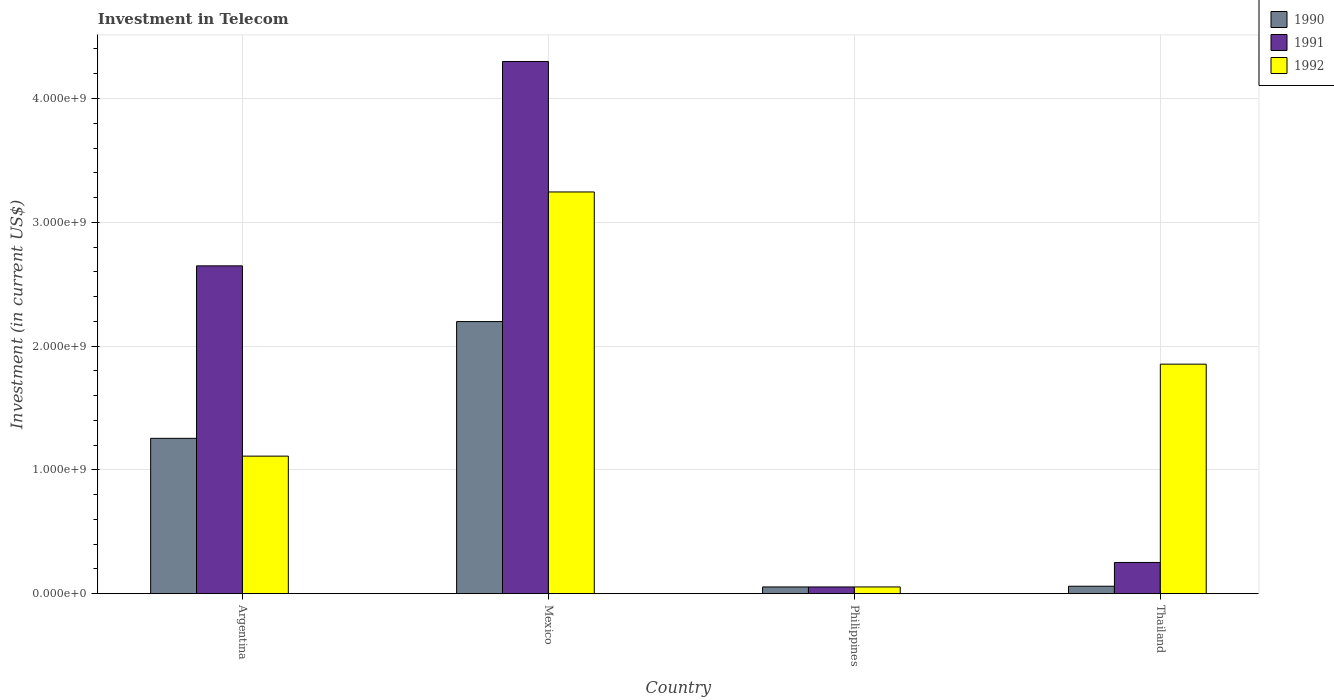How many different coloured bars are there?
Give a very brief answer. 3. How many groups of bars are there?
Provide a succinct answer. 4. Are the number of bars on each tick of the X-axis equal?
Your answer should be compact. Yes. How many bars are there on the 3rd tick from the left?
Give a very brief answer. 3. How many bars are there on the 3rd tick from the right?
Offer a terse response. 3. What is the label of the 2nd group of bars from the left?
Give a very brief answer. Mexico. What is the amount invested in telecom in 1991 in Thailand?
Make the answer very short. 2.52e+08. Across all countries, what is the maximum amount invested in telecom in 1990?
Your answer should be very brief. 2.20e+09. Across all countries, what is the minimum amount invested in telecom in 1991?
Give a very brief answer. 5.42e+07. In which country was the amount invested in telecom in 1990 minimum?
Give a very brief answer. Philippines. What is the total amount invested in telecom in 1991 in the graph?
Give a very brief answer. 7.25e+09. What is the difference between the amount invested in telecom in 1992 in Mexico and that in Philippines?
Your answer should be very brief. 3.19e+09. What is the difference between the amount invested in telecom in 1991 in Mexico and the amount invested in telecom in 1990 in Philippines?
Provide a short and direct response. 4.24e+09. What is the average amount invested in telecom in 1992 per country?
Your answer should be very brief. 1.57e+09. What is the difference between the amount invested in telecom of/in 1992 and amount invested in telecom of/in 1991 in Argentina?
Provide a succinct answer. -1.54e+09. What is the ratio of the amount invested in telecom in 1991 in Argentina to that in Thailand?
Your answer should be very brief. 10.51. Is the amount invested in telecom in 1990 in Philippines less than that in Thailand?
Offer a very short reply. Yes. What is the difference between the highest and the second highest amount invested in telecom in 1990?
Offer a very short reply. 2.14e+09. What is the difference between the highest and the lowest amount invested in telecom in 1992?
Ensure brevity in your answer.  3.19e+09. What does the 3rd bar from the right in Thailand represents?
Keep it short and to the point. 1990. Is it the case that in every country, the sum of the amount invested in telecom in 1990 and amount invested in telecom in 1992 is greater than the amount invested in telecom in 1991?
Make the answer very short. No. Are all the bars in the graph horizontal?
Make the answer very short. No. What is the difference between two consecutive major ticks on the Y-axis?
Offer a very short reply. 1.00e+09. How many legend labels are there?
Your response must be concise. 3. How are the legend labels stacked?
Your answer should be compact. Vertical. What is the title of the graph?
Your answer should be compact. Investment in Telecom. What is the label or title of the Y-axis?
Ensure brevity in your answer.  Investment (in current US$). What is the Investment (in current US$) of 1990 in Argentina?
Offer a terse response. 1.25e+09. What is the Investment (in current US$) of 1991 in Argentina?
Provide a short and direct response. 2.65e+09. What is the Investment (in current US$) of 1992 in Argentina?
Give a very brief answer. 1.11e+09. What is the Investment (in current US$) of 1990 in Mexico?
Your response must be concise. 2.20e+09. What is the Investment (in current US$) of 1991 in Mexico?
Offer a very short reply. 4.30e+09. What is the Investment (in current US$) in 1992 in Mexico?
Make the answer very short. 3.24e+09. What is the Investment (in current US$) in 1990 in Philippines?
Your answer should be compact. 5.42e+07. What is the Investment (in current US$) of 1991 in Philippines?
Make the answer very short. 5.42e+07. What is the Investment (in current US$) of 1992 in Philippines?
Make the answer very short. 5.42e+07. What is the Investment (in current US$) in 1990 in Thailand?
Your response must be concise. 6.00e+07. What is the Investment (in current US$) of 1991 in Thailand?
Give a very brief answer. 2.52e+08. What is the Investment (in current US$) in 1992 in Thailand?
Your response must be concise. 1.85e+09. Across all countries, what is the maximum Investment (in current US$) of 1990?
Your answer should be very brief. 2.20e+09. Across all countries, what is the maximum Investment (in current US$) of 1991?
Your response must be concise. 4.30e+09. Across all countries, what is the maximum Investment (in current US$) of 1992?
Provide a short and direct response. 3.24e+09. Across all countries, what is the minimum Investment (in current US$) of 1990?
Provide a short and direct response. 5.42e+07. Across all countries, what is the minimum Investment (in current US$) in 1991?
Ensure brevity in your answer.  5.42e+07. Across all countries, what is the minimum Investment (in current US$) in 1992?
Your answer should be very brief. 5.42e+07. What is the total Investment (in current US$) in 1990 in the graph?
Your response must be concise. 3.57e+09. What is the total Investment (in current US$) of 1991 in the graph?
Your response must be concise. 7.25e+09. What is the total Investment (in current US$) of 1992 in the graph?
Your response must be concise. 6.26e+09. What is the difference between the Investment (in current US$) in 1990 in Argentina and that in Mexico?
Provide a succinct answer. -9.43e+08. What is the difference between the Investment (in current US$) in 1991 in Argentina and that in Mexico?
Your response must be concise. -1.65e+09. What is the difference between the Investment (in current US$) in 1992 in Argentina and that in Mexico?
Your answer should be very brief. -2.13e+09. What is the difference between the Investment (in current US$) in 1990 in Argentina and that in Philippines?
Your answer should be very brief. 1.20e+09. What is the difference between the Investment (in current US$) in 1991 in Argentina and that in Philippines?
Make the answer very short. 2.59e+09. What is the difference between the Investment (in current US$) in 1992 in Argentina and that in Philippines?
Your answer should be very brief. 1.06e+09. What is the difference between the Investment (in current US$) in 1990 in Argentina and that in Thailand?
Ensure brevity in your answer.  1.19e+09. What is the difference between the Investment (in current US$) in 1991 in Argentina and that in Thailand?
Your answer should be very brief. 2.40e+09. What is the difference between the Investment (in current US$) of 1992 in Argentina and that in Thailand?
Give a very brief answer. -7.43e+08. What is the difference between the Investment (in current US$) in 1990 in Mexico and that in Philippines?
Your answer should be very brief. 2.14e+09. What is the difference between the Investment (in current US$) in 1991 in Mexico and that in Philippines?
Your response must be concise. 4.24e+09. What is the difference between the Investment (in current US$) of 1992 in Mexico and that in Philippines?
Make the answer very short. 3.19e+09. What is the difference between the Investment (in current US$) in 1990 in Mexico and that in Thailand?
Ensure brevity in your answer.  2.14e+09. What is the difference between the Investment (in current US$) of 1991 in Mexico and that in Thailand?
Your response must be concise. 4.05e+09. What is the difference between the Investment (in current US$) of 1992 in Mexico and that in Thailand?
Your answer should be compact. 1.39e+09. What is the difference between the Investment (in current US$) of 1990 in Philippines and that in Thailand?
Ensure brevity in your answer.  -5.80e+06. What is the difference between the Investment (in current US$) of 1991 in Philippines and that in Thailand?
Your response must be concise. -1.98e+08. What is the difference between the Investment (in current US$) in 1992 in Philippines and that in Thailand?
Offer a terse response. -1.80e+09. What is the difference between the Investment (in current US$) in 1990 in Argentina and the Investment (in current US$) in 1991 in Mexico?
Offer a terse response. -3.04e+09. What is the difference between the Investment (in current US$) of 1990 in Argentina and the Investment (in current US$) of 1992 in Mexico?
Provide a short and direct response. -1.99e+09. What is the difference between the Investment (in current US$) in 1991 in Argentina and the Investment (in current US$) in 1992 in Mexico?
Your response must be concise. -5.97e+08. What is the difference between the Investment (in current US$) of 1990 in Argentina and the Investment (in current US$) of 1991 in Philippines?
Your answer should be very brief. 1.20e+09. What is the difference between the Investment (in current US$) of 1990 in Argentina and the Investment (in current US$) of 1992 in Philippines?
Make the answer very short. 1.20e+09. What is the difference between the Investment (in current US$) of 1991 in Argentina and the Investment (in current US$) of 1992 in Philippines?
Your answer should be very brief. 2.59e+09. What is the difference between the Investment (in current US$) in 1990 in Argentina and the Investment (in current US$) in 1991 in Thailand?
Your answer should be compact. 1.00e+09. What is the difference between the Investment (in current US$) of 1990 in Argentina and the Investment (in current US$) of 1992 in Thailand?
Provide a short and direct response. -5.99e+08. What is the difference between the Investment (in current US$) of 1991 in Argentina and the Investment (in current US$) of 1992 in Thailand?
Provide a short and direct response. 7.94e+08. What is the difference between the Investment (in current US$) in 1990 in Mexico and the Investment (in current US$) in 1991 in Philippines?
Offer a terse response. 2.14e+09. What is the difference between the Investment (in current US$) in 1990 in Mexico and the Investment (in current US$) in 1992 in Philippines?
Your response must be concise. 2.14e+09. What is the difference between the Investment (in current US$) of 1991 in Mexico and the Investment (in current US$) of 1992 in Philippines?
Your answer should be very brief. 4.24e+09. What is the difference between the Investment (in current US$) of 1990 in Mexico and the Investment (in current US$) of 1991 in Thailand?
Your response must be concise. 1.95e+09. What is the difference between the Investment (in current US$) of 1990 in Mexico and the Investment (in current US$) of 1992 in Thailand?
Give a very brief answer. 3.44e+08. What is the difference between the Investment (in current US$) of 1991 in Mexico and the Investment (in current US$) of 1992 in Thailand?
Your response must be concise. 2.44e+09. What is the difference between the Investment (in current US$) in 1990 in Philippines and the Investment (in current US$) in 1991 in Thailand?
Offer a very short reply. -1.98e+08. What is the difference between the Investment (in current US$) in 1990 in Philippines and the Investment (in current US$) in 1992 in Thailand?
Your response must be concise. -1.80e+09. What is the difference between the Investment (in current US$) in 1991 in Philippines and the Investment (in current US$) in 1992 in Thailand?
Your answer should be compact. -1.80e+09. What is the average Investment (in current US$) of 1990 per country?
Give a very brief answer. 8.92e+08. What is the average Investment (in current US$) in 1991 per country?
Provide a short and direct response. 1.81e+09. What is the average Investment (in current US$) in 1992 per country?
Provide a short and direct response. 1.57e+09. What is the difference between the Investment (in current US$) in 1990 and Investment (in current US$) in 1991 in Argentina?
Make the answer very short. -1.39e+09. What is the difference between the Investment (in current US$) in 1990 and Investment (in current US$) in 1992 in Argentina?
Provide a short and direct response. 1.44e+08. What is the difference between the Investment (in current US$) of 1991 and Investment (in current US$) of 1992 in Argentina?
Keep it short and to the point. 1.54e+09. What is the difference between the Investment (in current US$) of 1990 and Investment (in current US$) of 1991 in Mexico?
Provide a short and direct response. -2.10e+09. What is the difference between the Investment (in current US$) in 1990 and Investment (in current US$) in 1992 in Mexico?
Your answer should be compact. -1.05e+09. What is the difference between the Investment (in current US$) of 1991 and Investment (in current US$) of 1992 in Mexico?
Your response must be concise. 1.05e+09. What is the difference between the Investment (in current US$) in 1990 and Investment (in current US$) in 1992 in Philippines?
Give a very brief answer. 0. What is the difference between the Investment (in current US$) of 1991 and Investment (in current US$) of 1992 in Philippines?
Make the answer very short. 0. What is the difference between the Investment (in current US$) of 1990 and Investment (in current US$) of 1991 in Thailand?
Your response must be concise. -1.92e+08. What is the difference between the Investment (in current US$) in 1990 and Investment (in current US$) in 1992 in Thailand?
Your answer should be compact. -1.79e+09. What is the difference between the Investment (in current US$) in 1991 and Investment (in current US$) in 1992 in Thailand?
Provide a succinct answer. -1.60e+09. What is the ratio of the Investment (in current US$) in 1990 in Argentina to that in Mexico?
Offer a very short reply. 0.57. What is the ratio of the Investment (in current US$) in 1991 in Argentina to that in Mexico?
Ensure brevity in your answer.  0.62. What is the ratio of the Investment (in current US$) in 1992 in Argentina to that in Mexico?
Give a very brief answer. 0.34. What is the ratio of the Investment (in current US$) of 1990 in Argentina to that in Philippines?
Offer a terse response. 23.15. What is the ratio of the Investment (in current US$) of 1991 in Argentina to that in Philippines?
Offer a terse response. 48.86. What is the ratio of the Investment (in current US$) of 1992 in Argentina to that in Philippines?
Your answer should be very brief. 20.5. What is the ratio of the Investment (in current US$) in 1990 in Argentina to that in Thailand?
Provide a succinct answer. 20.91. What is the ratio of the Investment (in current US$) of 1991 in Argentina to that in Thailand?
Offer a very short reply. 10.51. What is the ratio of the Investment (in current US$) of 1992 in Argentina to that in Thailand?
Provide a short and direct response. 0.6. What is the ratio of the Investment (in current US$) of 1990 in Mexico to that in Philippines?
Provide a short and direct response. 40.55. What is the ratio of the Investment (in current US$) of 1991 in Mexico to that in Philippines?
Keep it short and to the point. 79.32. What is the ratio of the Investment (in current US$) in 1992 in Mexico to that in Philippines?
Provide a short and direct response. 59.87. What is the ratio of the Investment (in current US$) of 1990 in Mexico to that in Thailand?
Your answer should be very brief. 36.63. What is the ratio of the Investment (in current US$) of 1991 in Mexico to that in Thailand?
Your answer should be very brief. 17.06. What is the ratio of the Investment (in current US$) of 1992 in Mexico to that in Thailand?
Provide a succinct answer. 1.75. What is the ratio of the Investment (in current US$) in 1990 in Philippines to that in Thailand?
Your answer should be compact. 0.9. What is the ratio of the Investment (in current US$) in 1991 in Philippines to that in Thailand?
Make the answer very short. 0.22. What is the ratio of the Investment (in current US$) of 1992 in Philippines to that in Thailand?
Give a very brief answer. 0.03. What is the difference between the highest and the second highest Investment (in current US$) in 1990?
Give a very brief answer. 9.43e+08. What is the difference between the highest and the second highest Investment (in current US$) in 1991?
Make the answer very short. 1.65e+09. What is the difference between the highest and the second highest Investment (in current US$) of 1992?
Your response must be concise. 1.39e+09. What is the difference between the highest and the lowest Investment (in current US$) of 1990?
Provide a succinct answer. 2.14e+09. What is the difference between the highest and the lowest Investment (in current US$) of 1991?
Offer a terse response. 4.24e+09. What is the difference between the highest and the lowest Investment (in current US$) in 1992?
Your answer should be very brief. 3.19e+09. 